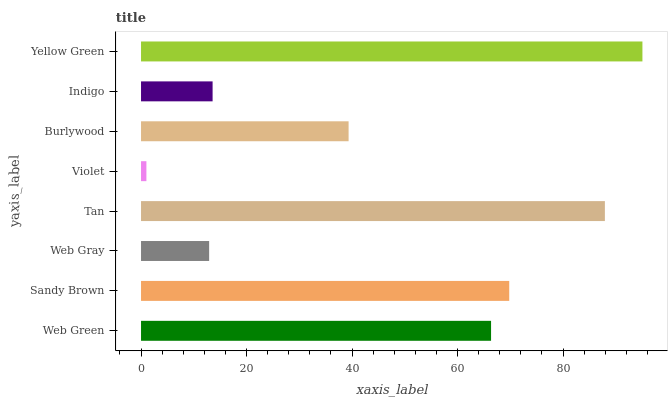Is Violet the minimum?
Answer yes or no. Yes. Is Yellow Green the maximum?
Answer yes or no. Yes. Is Sandy Brown the minimum?
Answer yes or no. No. Is Sandy Brown the maximum?
Answer yes or no. No. Is Sandy Brown greater than Web Green?
Answer yes or no. Yes. Is Web Green less than Sandy Brown?
Answer yes or no. Yes. Is Web Green greater than Sandy Brown?
Answer yes or no. No. Is Sandy Brown less than Web Green?
Answer yes or no. No. Is Web Green the high median?
Answer yes or no. Yes. Is Burlywood the low median?
Answer yes or no. Yes. Is Indigo the high median?
Answer yes or no. No. Is Yellow Green the low median?
Answer yes or no. No. 